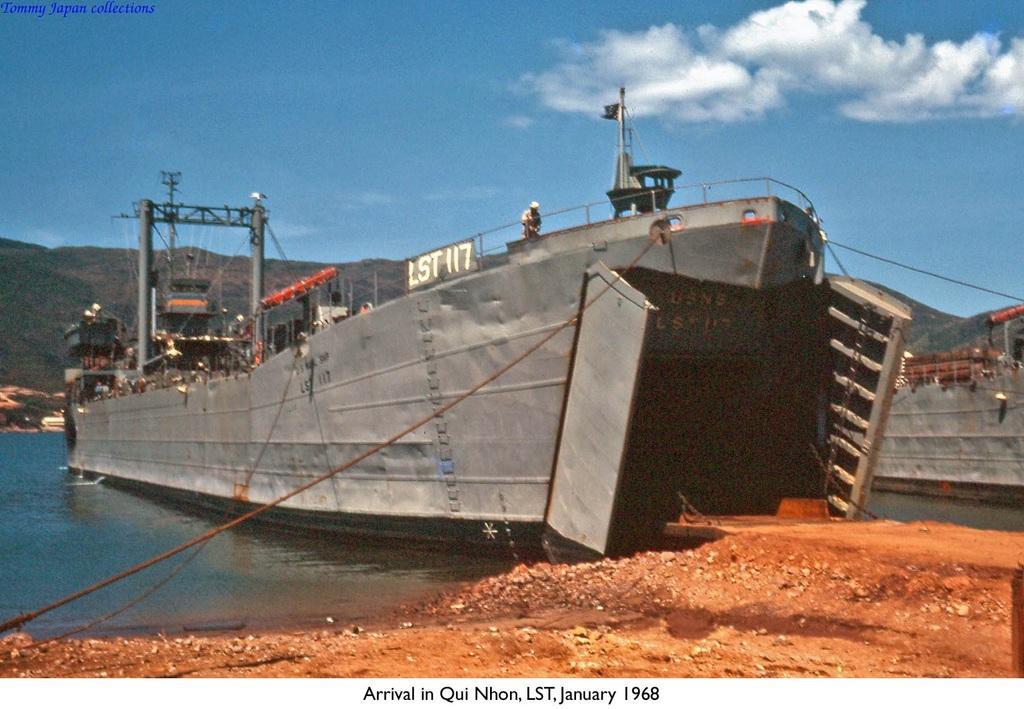Please provide a concise description of this image. On the right side, there is ground. In the background, there are ships parked on the water, there is a mountain, and there are clouds in the blue sky. 